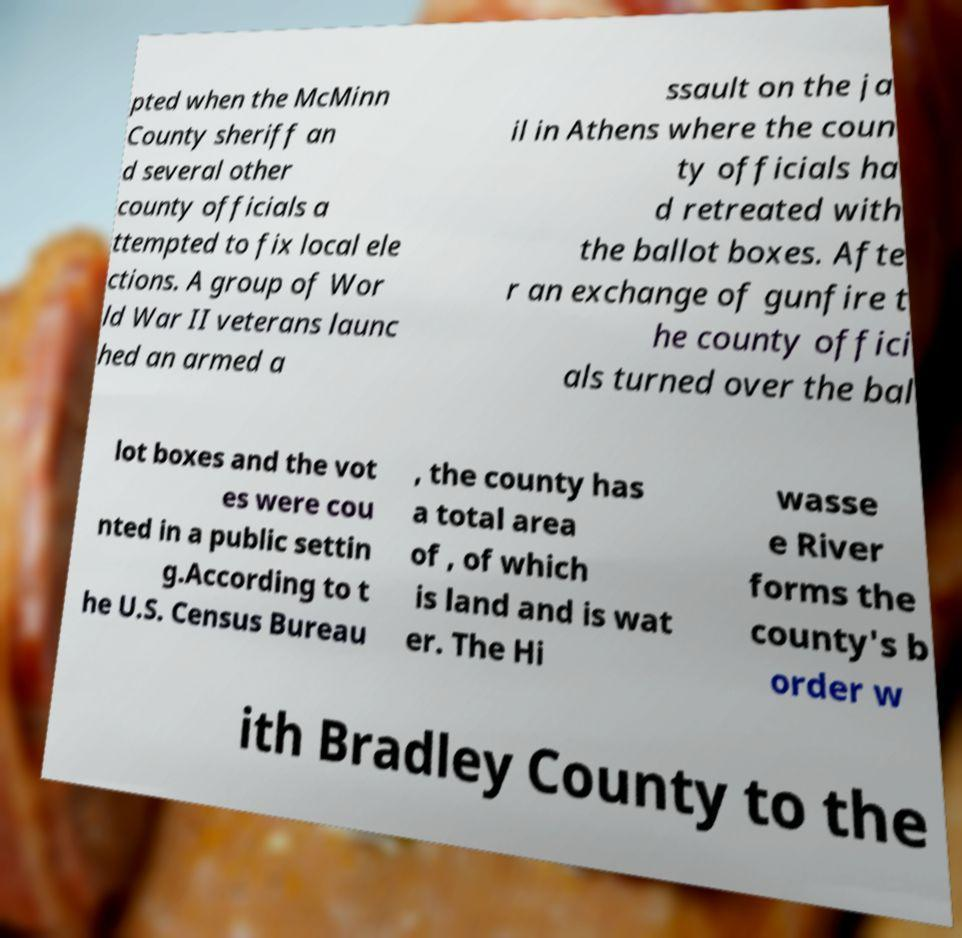Please identify and transcribe the text found in this image. pted when the McMinn County sheriff an d several other county officials a ttempted to fix local ele ctions. A group of Wor ld War II veterans launc hed an armed a ssault on the ja il in Athens where the coun ty officials ha d retreated with the ballot boxes. Afte r an exchange of gunfire t he county offici als turned over the bal lot boxes and the vot es were cou nted in a public settin g.According to t he U.S. Census Bureau , the county has a total area of , of which is land and is wat er. The Hi wasse e River forms the county's b order w ith Bradley County to the 